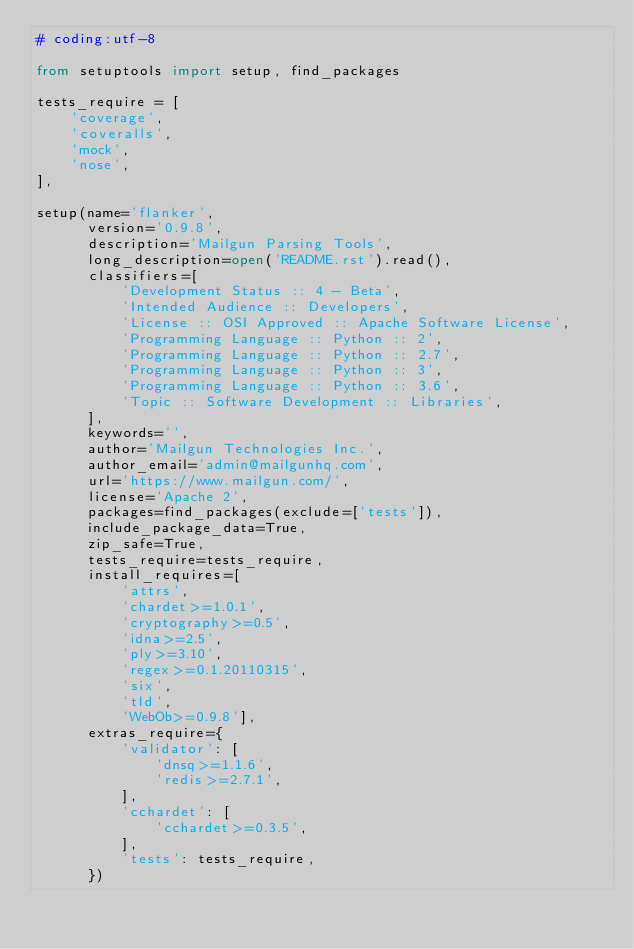<code> <loc_0><loc_0><loc_500><loc_500><_Python_># coding:utf-8

from setuptools import setup, find_packages

tests_require = [
    'coverage',
    'coveralls',
    'mock',
    'nose',
],

setup(name='flanker',
      version='0.9.8',
      description='Mailgun Parsing Tools',
      long_description=open('README.rst').read(),
      classifiers=[
          'Development Status :: 4 - Beta',
          'Intended Audience :: Developers',
          'License :: OSI Approved :: Apache Software License',
          'Programming Language :: Python :: 2',
          'Programming Language :: Python :: 2.7',
          'Programming Language :: Python :: 3',
          'Programming Language :: Python :: 3.6',
          'Topic :: Software Development :: Libraries',
      ],
      keywords='',
      author='Mailgun Technologies Inc.',
      author_email='admin@mailgunhq.com',
      url='https://www.mailgun.com/',
      license='Apache 2',
      packages=find_packages(exclude=['tests']),
      include_package_data=True,
      zip_safe=True,
      tests_require=tests_require,
      install_requires=[
          'attrs',
          'chardet>=1.0.1',
          'cryptography>=0.5',
          'idna>=2.5',
          'ply>=3.10',
          'regex>=0.1.20110315',
          'six',
          'tld',
          'WebOb>=0.9.8'],
      extras_require={
          'validator': [
              'dnsq>=1.1.6',
              'redis>=2.7.1',
          ],
          'cchardet': [
              'cchardet>=0.3.5',
          ],
          'tests': tests_require,
      })
</code> 